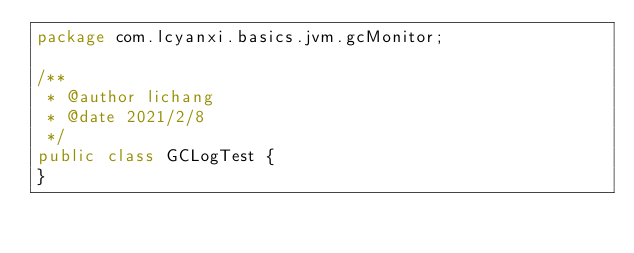Convert code to text. <code><loc_0><loc_0><loc_500><loc_500><_Java_>package com.lcyanxi.basics.jvm.gcMonitor;

/**
 * @author lichang
 * @date 2021/2/8
 */
public class GCLogTest {
}
</code> 